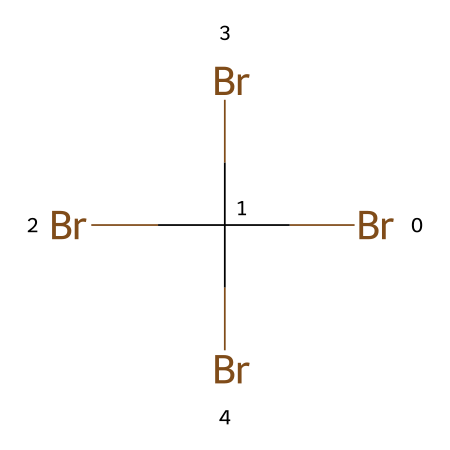How many bromine atoms are present in this structure? By examining the SMILES notation, there are four instances of the 'Br' symbol, each representing a bromine atom. Therefore, we can count a total of four bromine atoms in the chemical structure.
Answer: four What is the name of this chemical? The SMILES representation corresponds to tetrabromomethane, which is a bromine derivative with four bromine substitutions on a methane backbone.
Answer: tetrabromomethane What type of chemical compound is represented here? In this case, the compound consists only of carbon and bromine, making it a halogenated hydrocarbon. Hydrocarbons are compounds mostly formed from carbon and hydrogen, but in this case, bromine replaces the hydrogen atoms.
Answer: halogenated hydrocarbon What is the molecular formula of this chemical? The molecular formula can be derived from the SMILES, where there are four bromine atoms and one carbon atom, resulting in CBr4 as the molecular formula.
Answer: CBr4 What physical property is likely to be high due to the heavy bromine content? Due to the presence of multiple bromine atoms, which are heavier than hydrogen, the compound is expected to have a high density. Density is typically increased in substances with heavier halogen atoms.
Answer: density What is a common use of this type of compound? Tetrabromomethane is commonly used as a flame retardant due to its ability to effectively inhibit combustion. Flame retardants are used in various materials to enhance fire safety.
Answer: flame retardant Is this chemical likely to be volatile? Given the structure contains multiple bromine atoms, it is generally considered to have low volatility, as halogenated compounds with heavy atoms tend to evaporate less readily compared to lighter organic chemicals.
Answer: low volatility 